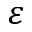Convert formula to latex. <formula><loc_0><loc_0><loc_500><loc_500>\varepsilon</formula> 